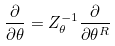Convert formula to latex. <formula><loc_0><loc_0><loc_500><loc_500>\frac { \partial } { \partial \theta } = Z _ { \theta } ^ { - 1 } \frac { \partial } { \partial \theta ^ { R } }</formula> 